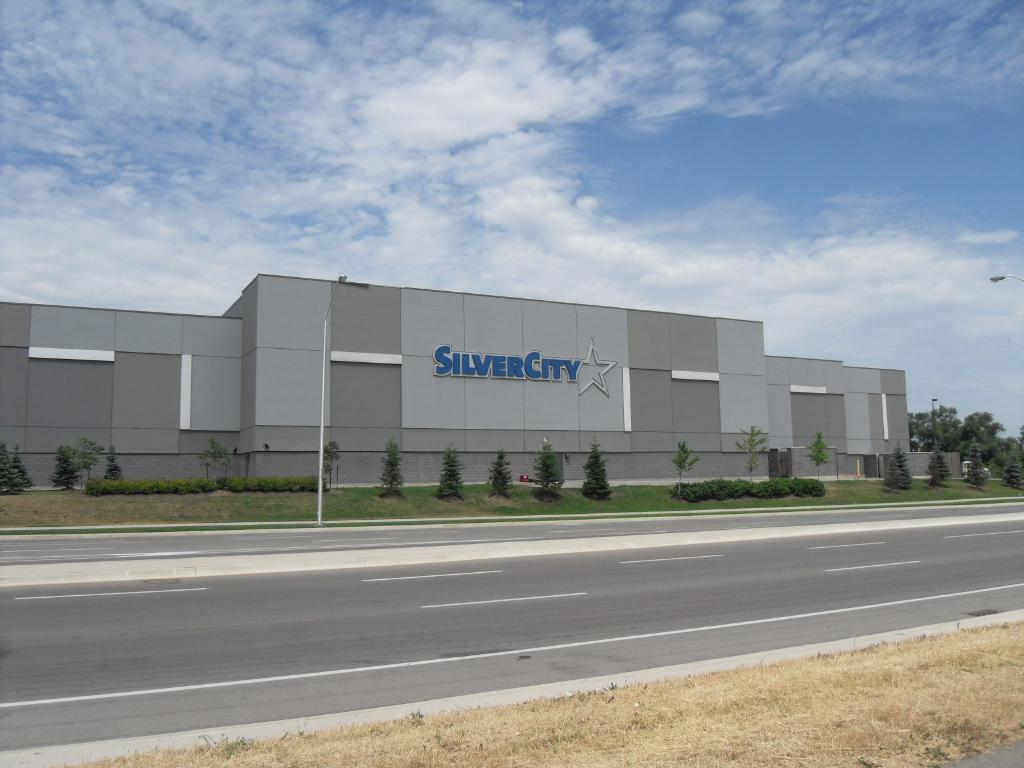What type of structure is present in the image? There is a building in the image. What feature is attached to the building? The building has a LED board attached to it. What type of vegetation can be seen in the image? There are trees and grass in the image. What type of lighting is visible in the image? Street lights are visible in the image. What can be seen in the background of the image? The sky is visible in the background of the image. What type of engine is visible in the image? There is no engine present in the image. Can you see a tramp performing in the image? There is no tramp performing in the image. 